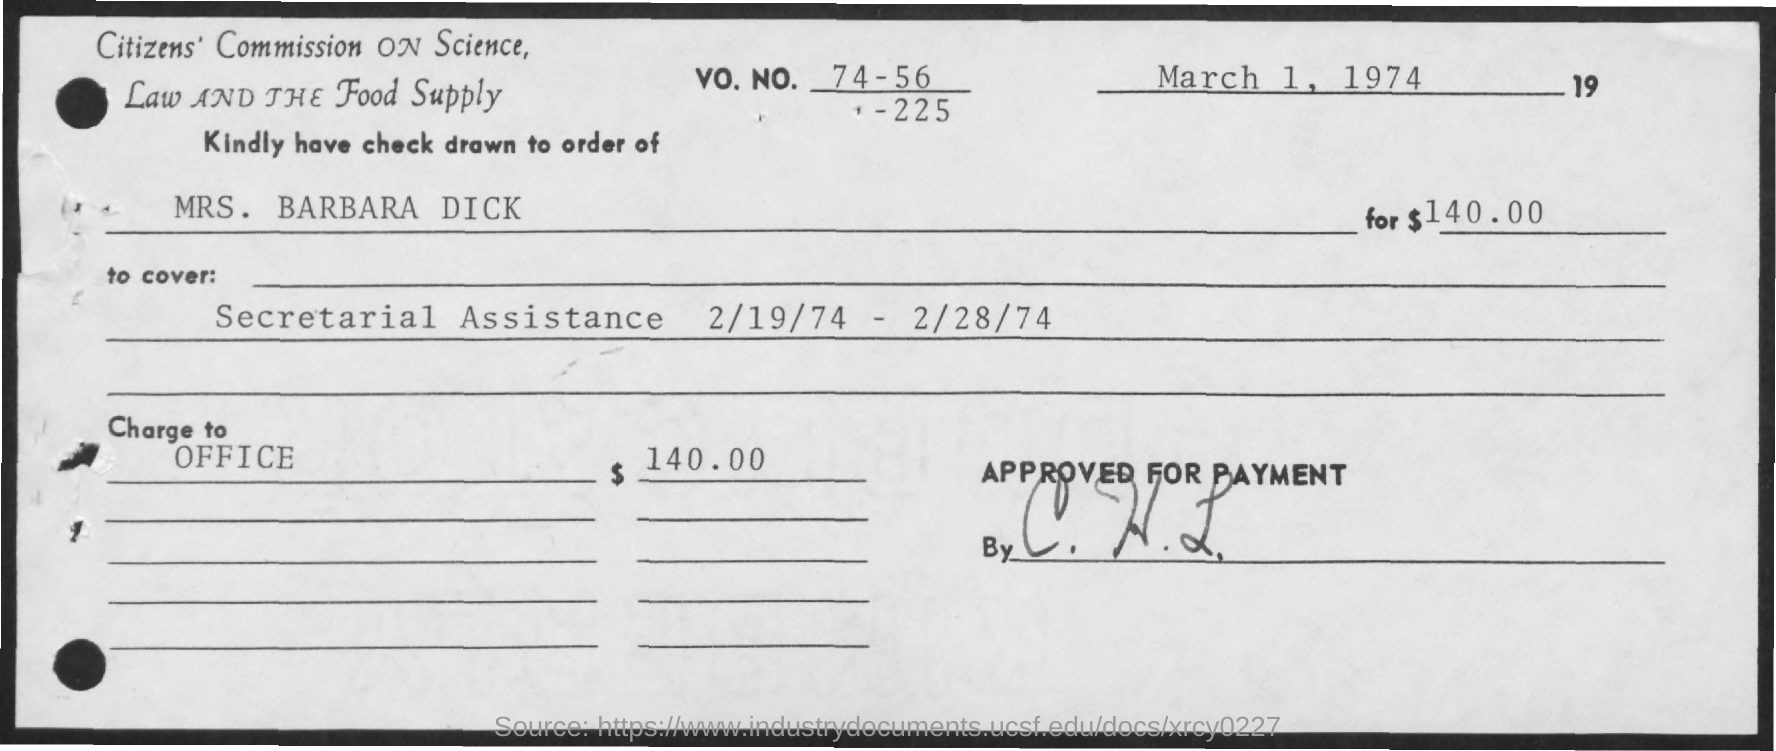What is the Vo. No. mentioned in the check?
Your answer should be compact. 74 - 56 -225. What is the issued date of the check?
Make the answer very short. March 1, 1974. What is the amount of check issued?
Offer a terse response. $140.00. In whose name, the check is issued?
Provide a succinct answer. Mrs. Barbara Dick. 